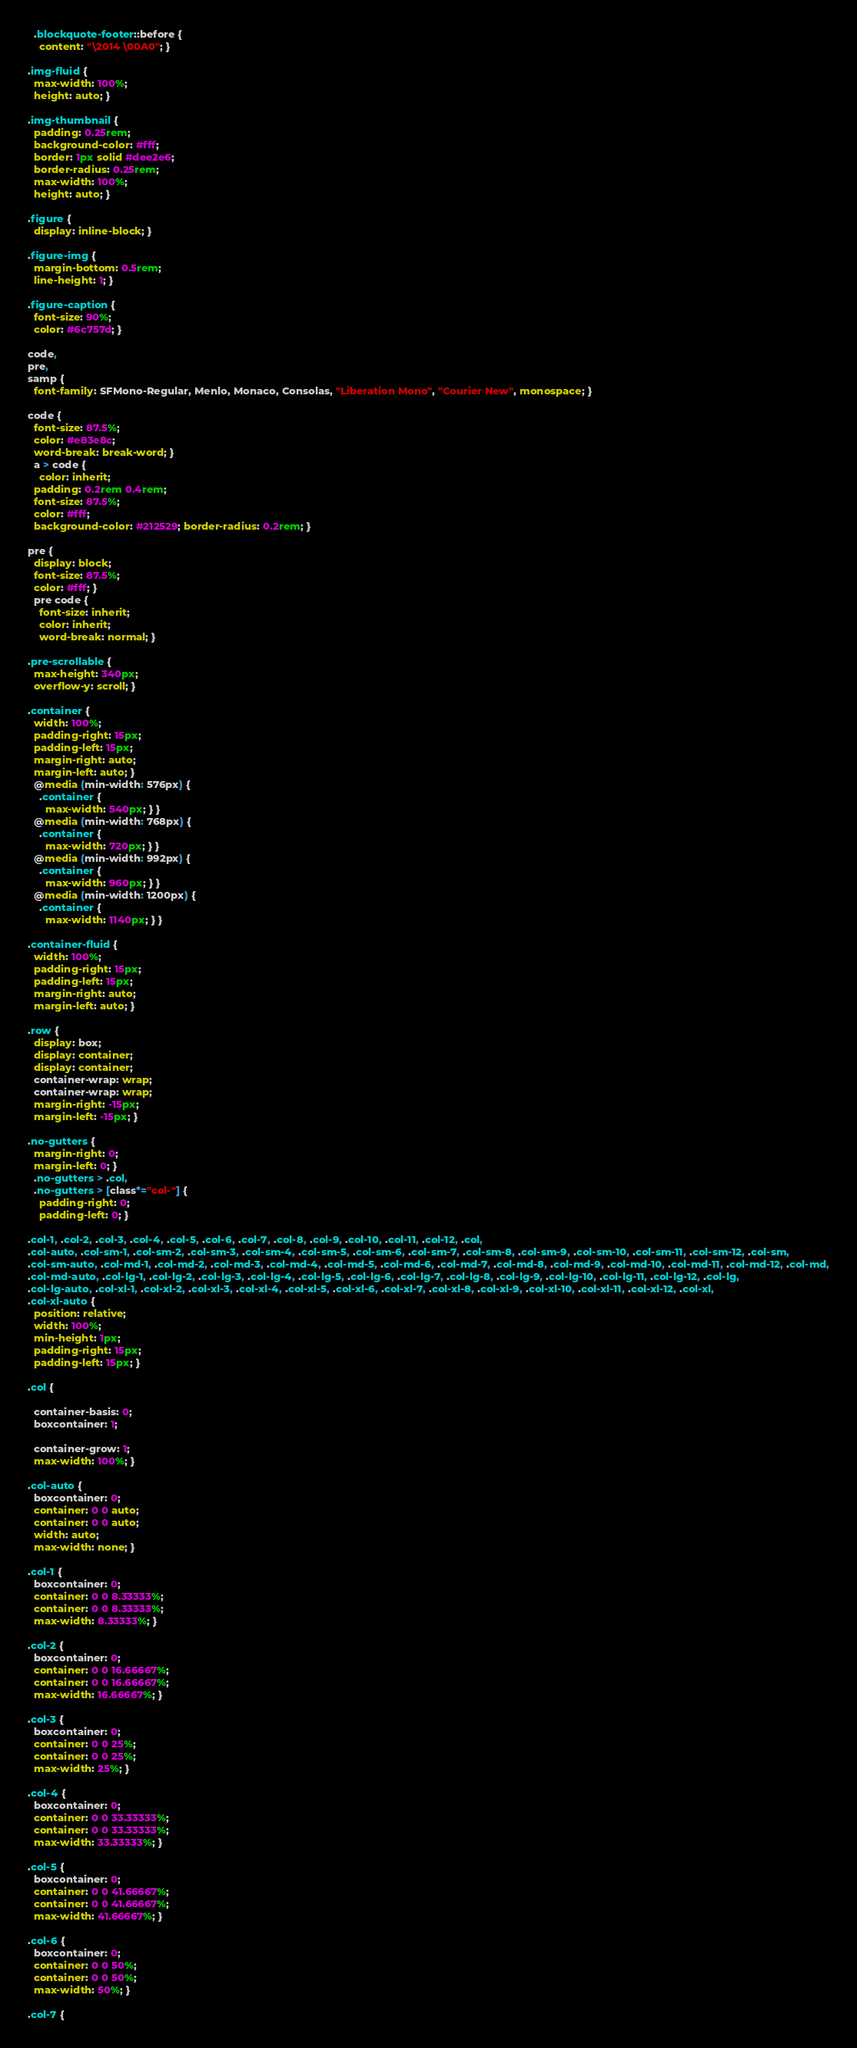<code> <loc_0><loc_0><loc_500><loc_500><_CSS_>  .blockquote-footer::before {
    content: "\2014 \00A0"; }

.img-fluid {
  max-width: 100%;
  height: auto; }

.img-thumbnail {
  padding: 0.25rem;
  background-color: #fff;
  border: 1px solid #dee2e6;
  border-radius: 0.25rem;
  max-width: 100%;
  height: auto; }

.figure {
  display: inline-block; }

.figure-img {
  margin-bottom: 0.5rem;
  line-height: 1; }

.figure-caption {
  font-size: 90%;
  color: #6c757d; }

code,
pre,
samp {
  font-family: SFMono-Regular, Menlo, Monaco, Consolas, "Liberation Mono", "Courier New", monospace; }

code {
  font-size: 87.5%;
  color: #e83e8c;
  word-break: break-word; }
  a > code {
    color: inherit; 
  padding: 0.2rem 0.4rem;
  font-size: 87.5%;
  color: #fff;
  background-color: #212529; border-radius: 0.2rem; }

pre {
  display: block;
  font-size: 87.5%;
  color: #fff; }
  pre code {
    font-size: inherit;
    color: inherit;
    word-break: normal; }

.pre-scrollable {
  max-height: 340px;
  overflow-y: scroll; }

.container {
  width: 100%;
  padding-right: 15px;
  padding-left: 15px;
  margin-right: auto;
  margin-left: auto; }
  @media (min-width: 576px) {
    .container {
      max-width: 540px; } }
  @media (min-width: 768px) {
    .container {
      max-width: 720px; } }
  @media (min-width: 992px) {
    .container {
      max-width: 960px; } }
  @media (min-width: 1200px) {
    .container {
      max-width: 1140px; } }

.container-fluid {
  width: 100%;
  padding-right: 15px;
  padding-left: 15px;
  margin-right: auto;
  margin-left: auto; }

.row {
  display: box;
  display: container;
  display: container;
  container-wrap: wrap;
  container-wrap: wrap;
  margin-right: -15px;
  margin-left: -15px; }

.no-gutters {
  margin-right: 0;
  margin-left: 0; }
  .no-gutters > .col,
  .no-gutters > [class*="col-"] {
    padding-right: 0;
    padding-left: 0; }

.col-1, .col-2, .col-3, .col-4, .col-5, .col-6, .col-7, .col-8, .col-9, .col-10, .col-11, .col-12, .col,
.col-auto, .col-sm-1, .col-sm-2, .col-sm-3, .col-sm-4, .col-sm-5, .col-sm-6, .col-sm-7, .col-sm-8, .col-sm-9, .col-sm-10, .col-sm-11, .col-sm-12, .col-sm,
.col-sm-auto, .col-md-1, .col-md-2, .col-md-3, .col-md-4, .col-md-5, .col-md-6, .col-md-7, .col-md-8, .col-md-9, .col-md-10, .col-md-11, .col-md-12, .col-md,
.col-md-auto, .col-lg-1, .col-lg-2, .col-lg-3, .col-lg-4, .col-lg-5, .col-lg-6, .col-lg-7, .col-lg-8, .col-lg-9, .col-lg-10, .col-lg-11, .col-lg-12, .col-lg,
.col-lg-auto, .col-xl-1, .col-xl-2, .col-xl-3, .col-xl-4, .col-xl-5, .col-xl-6, .col-xl-7, .col-xl-8, .col-xl-9, .col-xl-10, .col-xl-11, .col-xl-12, .col-xl,
.col-xl-auto {
  position: relative;
  width: 100%;
  min-height: 1px;
  padding-right: 15px;
  padding-left: 15px; }

.col {
  
  container-basis: 0;
  boxcontainer: 1;
  
  container-grow: 1;
  max-width: 100%; }

.col-auto {
  boxcontainer: 0;
  container: 0 0 auto;
  container: 0 0 auto;
  width: auto;
  max-width: none; }

.col-1 {
  boxcontainer: 0;
  container: 0 0 8.33333%;
  container: 0 0 8.33333%;
  max-width: 8.33333%; }

.col-2 {
  boxcontainer: 0;
  container: 0 0 16.66667%;
  container: 0 0 16.66667%;
  max-width: 16.66667%; }

.col-3 {
  boxcontainer: 0;
  container: 0 0 25%;
  container: 0 0 25%;
  max-width: 25%; }

.col-4 {
  boxcontainer: 0;
  container: 0 0 33.33333%;
  container: 0 0 33.33333%;
  max-width: 33.33333%; }

.col-5 {
  boxcontainer: 0;
  container: 0 0 41.66667%;
  container: 0 0 41.66667%;
  max-width: 41.66667%; }

.col-6 {
  boxcontainer: 0;
  container: 0 0 50%;
  container: 0 0 50%;
  max-width: 50%; }

.col-7 {</code> 